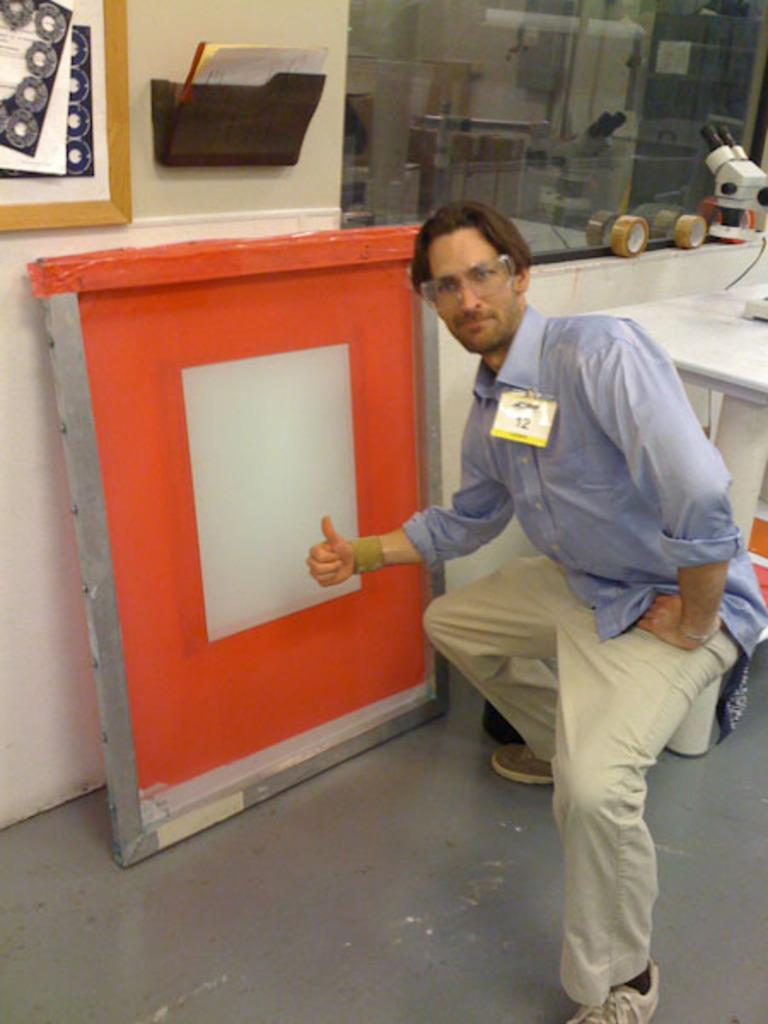What is the man in the image doing? The man is sitting in a squat position. What is located behind the man? There is a table behind the man. What can be seen on the wall in the image? There is a frame on the wall. What objects are present in the image besides the man and table? There is a board and a glass in the image. What type of animal is depicted in the frame on the wall? There is no animal depicted in the frame on the wall; it is not mentioned in the provided facts. 